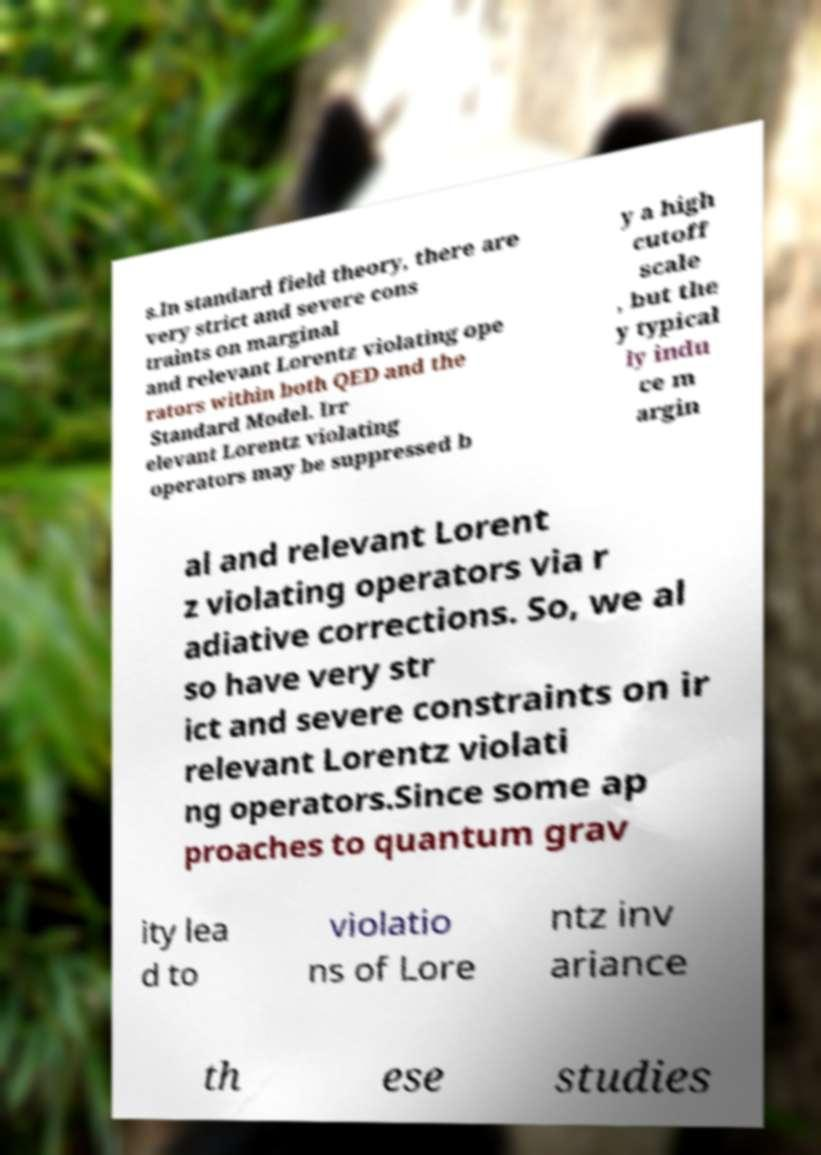Could you extract and type out the text from this image? s.In standard field theory, there are very strict and severe cons traints on marginal and relevant Lorentz violating ope rators within both QED and the Standard Model. Irr elevant Lorentz violating operators may be suppressed b y a high cutoff scale , but the y typical ly indu ce m argin al and relevant Lorent z violating operators via r adiative corrections. So, we al so have very str ict and severe constraints on ir relevant Lorentz violati ng operators.Since some ap proaches to quantum grav ity lea d to violatio ns of Lore ntz inv ariance th ese studies 